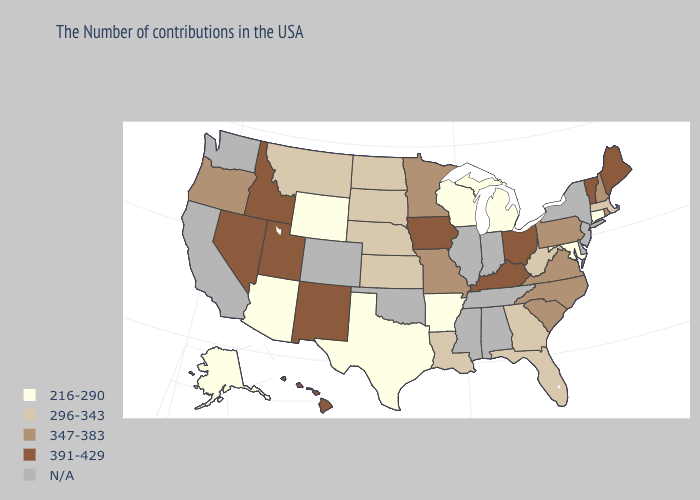Name the states that have a value in the range 347-383?
Write a very short answer. Rhode Island, New Hampshire, Pennsylvania, Virginia, North Carolina, South Carolina, Missouri, Minnesota, Oregon. Name the states that have a value in the range N/A?
Give a very brief answer. New York, New Jersey, Delaware, Indiana, Alabama, Tennessee, Illinois, Mississippi, Oklahoma, Colorado, California, Washington. Name the states that have a value in the range 391-429?
Be succinct. Maine, Vermont, Ohio, Kentucky, Iowa, New Mexico, Utah, Idaho, Nevada, Hawaii. Name the states that have a value in the range 296-343?
Keep it brief. Massachusetts, West Virginia, Florida, Georgia, Louisiana, Kansas, Nebraska, South Dakota, North Dakota, Montana. Does Minnesota have the highest value in the USA?
Write a very short answer. No. What is the value of Illinois?
Answer briefly. N/A. Which states have the lowest value in the West?
Be succinct. Wyoming, Arizona, Alaska. What is the value of Pennsylvania?
Keep it brief. 347-383. What is the value of Colorado?
Keep it brief. N/A. Name the states that have a value in the range 216-290?
Give a very brief answer. Connecticut, Maryland, Michigan, Wisconsin, Arkansas, Texas, Wyoming, Arizona, Alaska. Among the states that border California , does Nevada have the lowest value?
Write a very short answer. No. Among the states that border Nebraska , does Wyoming have the lowest value?
Concise answer only. Yes. How many symbols are there in the legend?
Answer briefly. 5. Does Michigan have the lowest value in the USA?
Write a very short answer. Yes. 